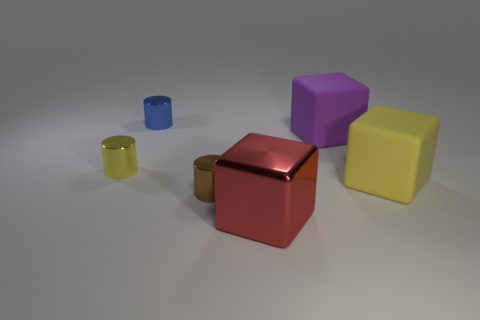There is a yellow object behind the yellow cube; is its size the same as the purple thing?
Provide a succinct answer. No. Is there a yellow cylinder that is behind the metal cylinder on the left side of the tiny blue cylinder?
Offer a very short reply. No. What is the tiny brown cylinder made of?
Provide a short and direct response. Metal. There is a purple rubber cube; are there any small brown metal cylinders to the right of it?
Provide a short and direct response. No. The yellow thing that is the same shape as the big purple matte thing is what size?
Ensure brevity in your answer.  Large. Is the number of blocks that are behind the large yellow rubber block the same as the number of tiny blue objects that are to the right of the big red object?
Give a very brief answer. No. What number of big yellow matte things are there?
Your response must be concise. 1. Is the number of brown objects that are in front of the large red metal cube greater than the number of yellow objects?
Ensure brevity in your answer.  No. There is a tiny thing that is left of the blue cylinder; what is it made of?
Offer a terse response. Metal. There is another big shiny thing that is the same shape as the big purple thing; what color is it?
Give a very brief answer. Red. 